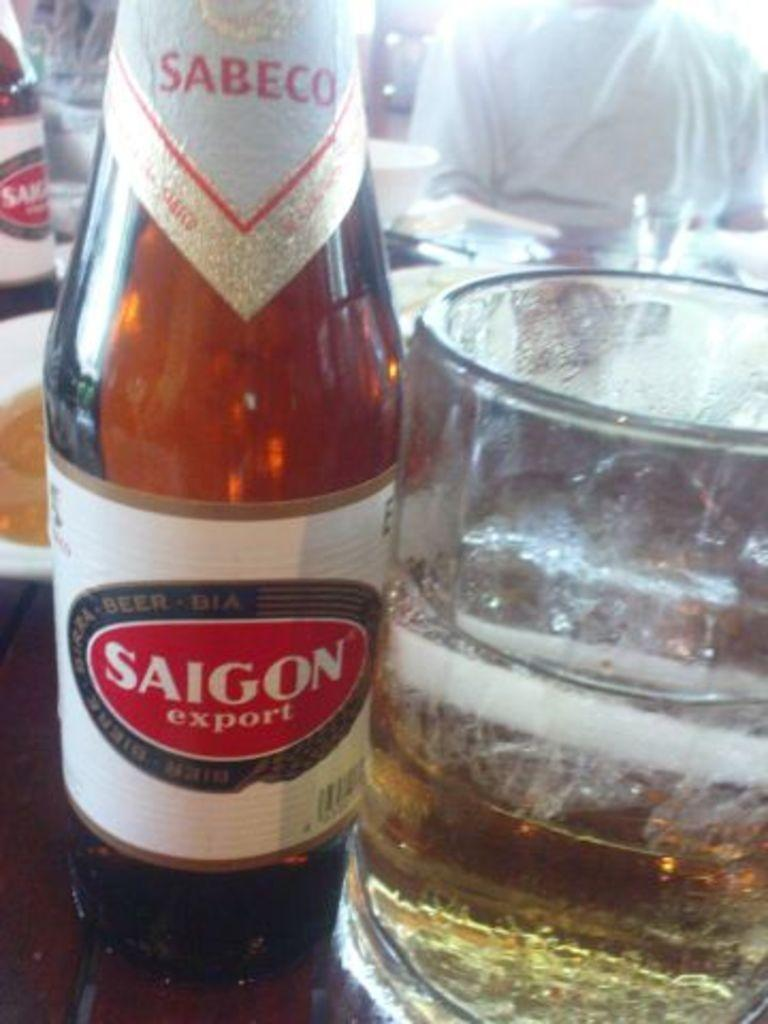<image>
Describe the image concisely. A bottle has a label with Saigon export. 